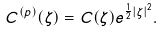Convert formula to latex. <formula><loc_0><loc_0><loc_500><loc_500>C ^ { ( p ) } ( \zeta ) = C ( \zeta ) e ^ { \frac { 1 } { 2 } | \zeta | ^ { 2 } } .</formula> 